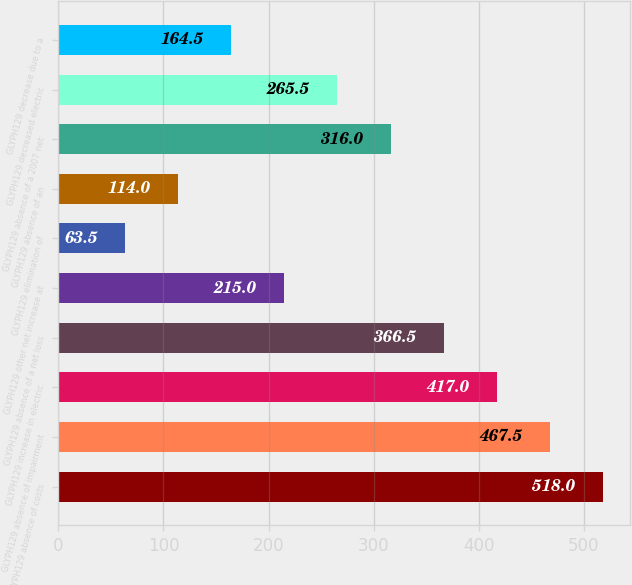Convert chart. <chart><loc_0><loc_0><loc_500><loc_500><bar_chart><fcel>GLYPH129 absence of costs<fcel>GLYPH129 absence of impairment<fcel>GLYPH129 increase in electric<fcel>GLYPH129 absence of a net loss<fcel>GLYPH129 other net increase at<fcel>GLYPH129 elimination of<fcel>GLYPH129 absence of an<fcel>GLYPH129 absence of a 2007 net<fcel>GLYPH129 decreased electric<fcel>GLYPH129 decrease due to a<nl><fcel>518<fcel>467.5<fcel>417<fcel>366.5<fcel>215<fcel>63.5<fcel>114<fcel>316<fcel>265.5<fcel>164.5<nl></chart> 